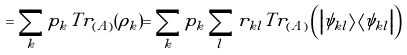Convert formula to latex. <formula><loc_0><loc_0><loc_500><loc_500>= \sum _ { k } p _ { k } T r _ { ( A ) } ( \rho _ { k } ) = \sum _ { k } p _ { k } \sum _ { l } r _ { k l } T r _ { ( A ) } \left ( \left | \psi _ { k l } \right \rangle \left \langle \psi _ { k l } \right | \right )</formula> 